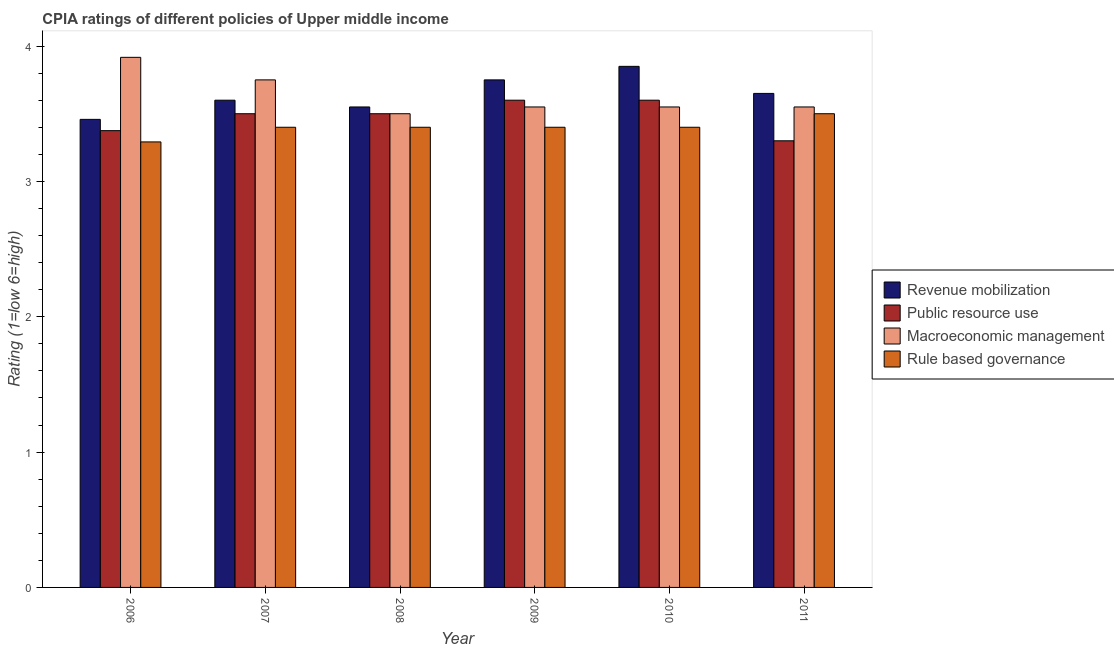How many groups of bars are there?
Keep it short and to the point. 6. Are the number of bars on each tick of the X-axis equal?
Provide a succinct answer. Yes. How many bars are there on the 2nd tick from the right?
Provide a short and direct response. 4. What is the label of the 4th group of bars from the left?
Your answer should be very brief. 2009. What is the cpia rating of rule based governance in 2010?
Your answer should be compact. 3.4. Across all years, what is the maximum cpia rating of revenue mobilization?
Keep it short and to the point. 3.85. Across all years, what is the minimum cpia rating of public resource use?
Make the answer very short. 3.3. In which year was the cpia rating of macroeconomic management maximum?
Offer a terse response. 2006. In which year was the cpia rating of revenue mobilization minimum?
Your answer should be very brief. 2006. What is the total cpia rating of rule based governance in the graph?
Keep it short and to the point. 20.39. What is the difference between the cpia rating of public resource use in 2006 and that in 2009?
Provide a short and direct response. -0.23. What is the difference between the cpia rating of revenue mobilization in 2008 and the cpia rating of macroeconomic management in 2007?
Offer a terse response. -0.05. What is the average cpia rating of rule based governance per year?
Your answer should be very brief. 3.4. In the year 2008, what is the difference between the cpia rating of public resource use and cpia rating of macroeconomic management?
Offer a very short reply. 0. In how many years, is the cpia rating of macroeconomic management greater than 3.4?
Offer a terse response. 6. What is the ratio of the cpia rating of rule based governance in 2010 to that in 2011?
Provide a short and direct response. 0.97. Is the cpia rating of public resource use in 2006 less than that in 2010?
Give a very brief answer. Yes. Is the difference between the cpia rating of rule based governance in 2008 and 2009 greater than the difference between the cpia rating of revenue mobilization in 2008 and 2009?
Provide a short and direct response. No. What is the difference between the highest and the second highest cpia rating of public resource use?
Provide a succinct answer. 0. What is the difference between the highest and the lowest cpia rating of revenue mobilization?
Make the answer very short. 0.39. Is the sum of the cpia rating of macroeconomic management in 2007 and 2010 greater than the maximum cpia rating of revenue mobilization across all years?
Keep it short and to the point. Yes. What does the 2nd bar from the left in 2007 represents?
Give a very brief answer. Public resource use. What does the 1st bar from the right in 2010 represents?
Provide a succinct answer. Rule based governance. Is it the case that in every year, the sum of the cpia rating of revenue mobilization and cpia rating of public resource use is greater than the cpia rating of macroeconomic management?
Ensure brevity in your answer.  Yes. Are all the bars in the graph horizontal?
Your answer should be compact. No. What is the difference between two consecutive major ticks on the Y-axis?
Give a very brief answer. 1. Are the values on the major ticks of Y-axis written in scientific E-notation?
Your answer should be very brief. No. Does the graph contain any zero values?
Give a very brief answer. No. Where does the legend appear in the graph?
Offer a very short reply. Center right. How many legend labels are there?
Keep it short and to the point. 4. What is the title of the graph?
Your response must be concise. CPIA ratings of different policies of Upper middle income. What is the label or title of the X-axis?
Provide a short and direct response. Year. What is the Rating (1=low 6=high) of Revenue mobilization in 2006?
Your answer should be compact. 3.46. What is the Rating (1=low 6=high) in Public resource use in 2006?
Offer a terse response. 3.38. What is the Rating (1=low 6=high) in Macroeconomic management in 2006?
Provide a short and direct response. 3.92. What is the Rating (1=low 6=high) in Rule based governance in 2006?
Provide a short and direct response. 3.29. What is the Rating (1=low 6=high) of Revenue mobilization in 2007?
Offer a terse response. 3.6. What is the Rating (1=low 6=high) of Macroeconomic management in 2007?
Provide a short and direct response. 3.75. What is the Rating (1=low 6=high) in Rule based governance in 2007?
Ensure brevity in your answer.  3.4. What is the Rating (1=low 6=high) of Revenue mobilization in 2008?
Give a very brief answer. 3.55. What is the Rating (1=low 6=high) of Rule based governance in 2008?
Ensure brevity in your answer.  3.4. What is the Rating (1=low 6=high) in Revenue mobilization in 2009?
Provide a succinct answer. 3.75. What is the Rating (1=low 6=high) of Macroeconomic management in 2009?
Offer a very short reply. 3.55. What is the Rating (1=low 6=high) of Rule based governance in 2009?
Provide a short and direct response. 3.4. What is the Rating (1=low 6=high) of Revenue mobilization in 2010?
Offer a terse response. 3.85. What is the Rating (1=low 6=high) in Public resource use in 2010?
Your response must be concise. 3.6. What is the Rating (1=low 6=high) in Macroeconomic management in 2010?
Your answer should be very brief. 3.55. What is the Rating (1=low 6=high) in Revenue mobilization in 2011?
Your answer should be very brief. 3.65. What is the Rating (1=low 6=high) in Macroeconomic management in 2011?
Your answer should be very brief. 3.55. Across all years, what is the maximum Rating (1=low 6=high) in Revenue mobilization?
Keep it short and to the point. 3.85. Across all years, what is the maximum Rating (1=low 6=high) of Public resource use?
Give a very brief answer. 3.6. Across all years, what is the maximum Rating (1=low 6=high) of Macroeconomic management?
Offer a very short reply. 3.92. Across all years, what is the minimum Rating (1=low 6=high) in Revenue mobilization?
Provide a succinct answer. 3.46. Across all years, what is the minimum Rating (1=low 6=high) in Public resource use?
Make the answer very short. 3.3. Across all years, what is the minimum Rating (1=low 6=high) in Macroeconomic management?
Your answer should be compact. 3.5. Across all years, what is the minimum Rating (1=low 6=high) of Rule based governance?
Your answer should be very brief. 3.29. What is the total Rating (1=low 6=high) of Revenue mobilization in the graph?
Your answer should be compact. 21.86. What is the total Rating (1=low 6=high) in Public resource use in the graph?
Your answer should be compact. 20.88. What is the total Rating (1=low 6=high) of Macroeconomic management in the graph?
Give a very brief answer. 21.82. What is the total Rating (1=low 6=high) in Rule based governance in the graph?
Make the answer very short. 20.39. What is the difference between the Rating (1=low 6=high) in Revenue mobilization in 2006 and that in 2007?
Offer a very short reply. -0.14. What is the difference between the Rating (1=low 6=high) of Public resource use in 2006 and that in 2007?
Provide a succinct answer. -0.12. What is the difference between the Rating (1=low 6=high) of Rule based governance in 2006 and that in 2007?
Your answer should be very brief. -0.11. What is the difference between the Rating (1=low 6=high) of Revenue mobilization in 2006 and that in 2008?
Offer a very short reply. -0.09. What is the difference between the Rating (1=low 6=high) in Public resource use in 2006 and that in 2008?
Give a very brief answer. -0.12. What is the difference between the Rating (1=low 6=high) of Macroeconomic management in 2006 and that in 2008?
Offer a terse response. 0.42. What is the difference between the Rating (1=low 6=high) in Rule based governance in 2006 and that in 2008?
Your answer should be very brief. -0.11. What is the difference between the Rating (1=low 6=high) of Revenue mobilization in 2006 and that in 2009?
Offer a very short reply. -0.29. What is the difference between the Rating (1=low 6=high) in Public resource use in 2006 and that in 2009?
Your response must be concise. -0.23. What is the difference between the Rating (1=low 6=high) of Macroeconomic management in 2006 and that in 2009?
Make the answer very short. 0.37. What is the difference between the Rating (1=low 6=high) in Rule based governance in 2006 and that in 2009?
Offer a terse response. -0.11. What is the difference between the Rating (1=low 6=high) of Revenue mobilization in 2006 and that in 2010?
Provide a succinct answer. -0.39. What is the difference between the Rating (1=low 6=high) in Public resource use in 2006 and that in 2010?
Your answer should be compact. -0.23. What is the difference between the Rating (1=low 6=high) of Macroeconomic management in 2006 and that in 2010?
Your answer should be compact. 0.37. What is the difference between the Rating (1=low 6=high) of Rule based governance in 2006 and that in 2010?
Your answer should be compact. -0.11. What is the difference between the Rating (1=low 6=high) of Revenue mobilization in 2006 and that in 2011?
Offer a very short reply. -0.19. What is the difference between the Rating (1=low 6=high) in Public resource use in 2006 and that in 2011?
Your answer should be compact. 0.07. What is the difference between the Rating (1=low 6=high) in Macroeconomic management in 2006 and that in 2011?
Offer a very short reply. 0.37. What is the difference between the Rating (1=low 6=high) in Rule based governance in 2006 and that in 2011?
Provide a short and direct response. -0.21. What is the difference between the Rating (1=low 6=high) in Public resource use in 2007 and that in 2008?
Ensure brevity in your answer.  0. What is the difference between the Rating (1=low 6=high) of Macroeconomic management in 2007 and that in 2008?
Give a very brief answer. 0.25. What is the difference between the Rating (1=low 6=high) in Rule based governance in 2007 and that in 2008?
Ensure brevity in your answer.  0. What is the difference between the Rating (1=low 6=high) of Revenue mobilization in 2007 and that in 2009?
Provide a short and direct response. -0.15. What is the difference between the Rating (1=low 6=high) in Public resource use in 2007 and that in 2009?
Your response must be concise. -0.1. What is the difference between the Rating (1=low 6=high) of Macroeconomic management in 2007 and that in 2009?
Offer a very short reply. 0.2. What is the difference between the Rating (1=low 6=high) in Rule based governance in 2007 and that in 2009?
Make the answer very short. 0. What is the difference between the Rating (1=low 6=high) in Public resource use in 2007 and that in 2011?
Provide a short and direct response. 0.2. What is the difference between the Rating (1=low 6=high) of Macroeconomic management in 2007 and that in 2011?
Your answer should be very brief. 0.2. What is the difference between the Rating (1=low 6=high) in Revenue mobilization in 2008 and that in 2009?
Keep it short and to the point. -0.2. What is the difference between the Rating (1=low 6=high) in Rule based governance in 2008 and that in 2010?
Provide a succinct answer. 0. What is the difference between the Rating (1=low 6=high) of Revenue mobilization in 2008 and that in 2011?
Your response must be concise. -0.1. What is the difference between the Rating (1=low 6=high) of Public resource use in 2008 and that in 2011?
Provide a succinct answer. 0.2. What is the difference between the Rating (1=low 6=high) in Macroeconomic management in 2008 and that in 2011?
Make the answer very short. -0.05. What is the difference between the Rating (1=low 6=high) of Revenue mobilization in 2009 and that in 2010?
Ensure brevity in your answer.  -0.1. What is the difference between the Rating (1=low 6=high) in Macroeconomic management in 2009 and that in 2010?
Make the answer very short. 0. What is the difference between the Rating (1=low 6=high) of Rule based governance in 2009 and that in 2010?
Your response must be concise. 0. What is the difference between the Rating (1=low 6=high) in Revenue mobilization in 2009 and that in 2011?
Your response must be concise. 0.1. What is the difference between the Rating (1=low 6=high) in Public resource use in 2009 and that in 2011?
Provide a short and direct response. 0.3. What is the difference between the Rating (1=low 6=high) of Rule based governance in 2009 and that in 2011?
Your answer should be very brief. -0.1. What is the difference between the Rating (1=low 6=high) of Revenue mobilization in 2006 and the Rating (1=low 6=high) of Public resource use in 2007?
Provide a succinct answer. -0.04. What is the difference between the Rating (1=low 6=high) in Revenue mobilization in 2006 and the Rating (1=low 6=high) in Macroeconomic management in 2007?
Provide a short and direct response. -0.29. What is the difference between the Rating (1=low 6=high) of Revenue mobilization in 2006 and the Rating (1=low 6=high) of Rule based governance in 2007?
Ensure brevity in your answer.  0.06. What is the difference between the Rating (1=low 6=high) of Public resource use in 2006 and the Rating (1=low 6=high) of Macroeconomic management in 2007?
Provide a short and direct response. -0.38. What is the difference between the Rating (1=low 6=high) in Public resource use in 2006 and the Rating (1=low 6=high) in Rule based governance in 2007?
Keep it short and to the point. -0.03. What is the difference between the Rating (1=low 6=high) in Macroeconomic management in 2006 and the Rating (1=low 6=high) in Rule based governance in 2007?
Your answer should be compact. 0.52. What is the difference between the Rating (1=low 6=high) in Revenue mobilization in 2006 and the Rating (1=low 6=high) in Public resource use in 2008?
Provide a succinct answer. -0.04. What is the difference between the Rating (1=low 6=high) in Revenue mobilization in 2006 and the Rating (1=low 6=high) in Macroeconomic management in 2008?
Offer a very short reply. -0.04. What is the difference between the Rating (1=low 6=high) of Revenue mobilization in 2006 and the Rating (1=low 6=high) of Rule based governance in 2008?
Ensure brevity in your answer.  0.06. What is the difference between the Rating (1=low 6=high) of Public resource use in 2006 and the Rating (1=low 6=high) of Macroeconomic management in 2008?
Keep it short and to the point. -0.12. What is the difference between the Rating (1=low 6=high) of Public resource use in 2006 and the Rating (1=low 6=high) of Rule based governance in 2008?
Provide a short and direct response. -0.03. What is the difference between the Rating (1=low 6=high) in Macroeconomic management in 2006 and the Rating (1=low 6=high) in Rule based governance in 2008?
Your response must be concise. 0.52. What is the difference between the Rating (1=low 6=high) in Revenue mobilization in 2006 and the Rating (1=low 6=high) in Public resource use in 2009?
Make the answer very short. -0.14. What is the difference between the Rating (1=low 6=high) in Revenue mobilization in 2006 and the Rating (1=low 6=high) in Macroeconomic management in 2009?
Your answer should be very brief. -0.09. What is the difference between the Rating (1=low 6=high) in Revenue mobilization in 2006 and the Rating (1=low 6=high) in Rule based governance in 2009?
Provide a short and direct response. 0.06. What is the difference between the Rating (1=low 6=high) of Public resource use in 2006 and the Rating (1=low 6=high) of Macroeconomic management in 2009?
Ensure brevity in your answer.  -0.17. What is the difference between the Rating (1=low 6=high) in Public resource use in 2006 and the Rating (1=low 6=high) in Rule based governance in 2009?
Make the answer very short. -0.03. What is the difference between the Rating (1=low 6=high) of Macroeconomic management in 2006 and the Rating (1=low 6=high) of Rule based governance in 2009?
Ensure brevity in your answer.  0.52. What is the difference between the Rating (1=low 6=high) of Revenue mobilization in 2006 and the Rating (1=low 6=high) of Public resource use in 2010?
Ensure brevity in your answer.  -0.14. What is the difference between the Rating (1=low 6=high) in Revenue mobilization in 2006 and the Rating (1=low 6=high) in Macroeconomic management in 2010?
Provide a short and direct response. -0.09. What is the difference between the Rating (1=low 6=high) of Revenue mobilization in 2006 and the Rating (1=low 6=high) of Rule based governance in 2010?
Your answer should be very brief. 0.06. What is the difference between the Rating (1=low 6=high) of Public resource use in 2006 and the Rating (1=low 6=high) of Macroeconomic management in 2010?
Give a very brief answer. -0.17. What is the difference between the Rating (1=low 6=high) of Public resource use in 2006 and the Rating (1=low 6=high) of Rule based governance in 2010?
Offer a very short reply. -0.03. What is the difference between the Rating (1=low 6=high) of Macroeconomic management in 2006 and the Rating (1=low 6=high) of Rule based governance in 2010?
Your answer should be compact. 0.52. What is the difference between the Rating (1=low 6=high) of Revenue mobilization in 2006 and the Rating (1=low 6=high) of Public resource use in 2011?
Make the answer very short. 0.16. What is the difference between the Rating (1=low 6=high) in Revenue mobilization in 2006 and the Rating (1=low 6=high) in Macroeconomic management in 2011?
Ensure brevity in your answer.  -0.09. What is the difference between the Rating (1=low 6=high) in Revenue mobilization in 2006 and the Rating (1=low 6=high) in Rule based governance in 2011?
Offer a very short reply. -0.04. What is the difference between the Rating (1=low 6=high) of Public resource use in 2006 and the Rating (1=low 6=high) of Macroeconomic management in 2011?
Your response must be concise. -0.17. What is the difference between the Rating (1=low 6=high) in Public resource use in 2006 and the Rating (1=low 6=high) in Rule based governance in 2011?
Your answer should be compact. -0.12. What is the difference between the Rating (1=low 6=high) in Macroeconomic management in 2006 and the Rating (1=low 6=high) in Rule based governance in 2011?
Your answer should be very brief. 0.42. What is the difference between the Rating (1=low 6=high) in Revenue mobilization in 2007 and the Rating (1=low 6=high) in Rule based governance in 2008?
Make the answer very short. 0.2. What is the difference between the Rating (1=low 6=high) in Public resource use in 2007 and the Rating (1=low 6=high) in Macroeconomic management in 2008?
Give a very brief answer. 0. What is the difference between the Rating (1=low 6=high) in Macroeconomic management in 2007 and the Rating (1=low 6=high) in Rule based governance in 2008?
Your answer should be very brief. 0.35. What is the difference between the Rating (1=low 6=high) of Revenue mobilization in 2007 and the Rating (1=low 6=high) of Macroeconomic management in 2009?
Provide a short and direct response. 0.05. What is the difference between the Rating (1=low 6=high) of Public resource use in 2007 and the Rating (1=low 6=high) of Macroeconomic management in 2009?
Make the answer very short. -0.05. What is the difference between the Rating (1=low 6=high) in Public resource use in 2007 and the Rating (1=low 6=high) in Rule based governance in 2009?
Ensure brevity in your answer.  0.1. What is the difference between the Rating (1=low 6=high) in Revenue mobilization in 2007 and the Rating (1=low 6=high) in Public resource use in 2010?
Provide a short and direct response. 0. What is the difference between the Rating (1=low 6=high) of Revenue mobilization in 2007 and the Rating (1=low 6=high) of Rule based governance in 2010?
Offer a very short reply. 0.2. What is the difference between the Rating (1=low 6=high) of Public resource use in 2007 and the Rating (1=low 6=high) of Macroeconomic management in 2010?
Ensure brevity in your answer.  -0.05. What is the difference between the Rating (1=low 6=high) of Revenue mobilization in 2007 and the Rating (1=low 6=high) of Rule based governance in 2011?
Your answer should be compact. 0.1. What is the difference between the Rating (1=low 6=high) in Macroeconomic management in 2007 and the Rating (1=low 6=high) in Rule based governance in 2011?
Your answer should be very brief. 0.25. What is the difference between the Rating (1=low 6=high) of Revenue mobilization in 2008 and the Rating (1=low 6=high) of Macroeconomic management in 2009?
Your response must be concise. 0. What is the difference between the Rating (1=low 6=high) of Revenue mobilization in 2008 and the Rating (1=low 6=high) of Rule based governance in 2009?
Your response must be concise. 0.15. What is the difference between the Rating (1=low 6=high) in Revenue mobilization in 2008 and the Rating (1=low 6=high) in Public resource use in 2010?
Ensure brevity in your answer.  -0.05. What is the difference between the Rating (1=low 6=high) of Revenue mobilization in 2008 and the Rating (1=low 6=high) of Macroeconomic management in 2010?
Offer a very short reply. 0. What is the difference between the Rating (1=low 6=high) in Public resource use in 2008 and the Rating (1=low 6=high) in Macroeconomic management in 2010?
Offer a terse response. -0.05. What is the difference between the Rating (1=low 6=high) in Macroeconomic management in 2008 and the Rating (1=low 6=high) in Rule based governance in 2010?
Your answer should be compact. 0.1. What is the difference between the Rating (1=low 6=high) in Revenue mobilization in 2008 and the Rating (1=low 6=high) in Macroeconomic management in 2011?
Your answer should be very brief. 0. What is the difference between the Rating (1=low 6=high) in Public resource use in 2008 and the Rating (1=low 6=high) in Macroeconomic management in 2011?
Offer a very short reply. -0.05. What is the difference between the Rating (1=low 6=high) of Macroeconomic management in 2008 and the Rating (1=low 6=high) of Rule based governance in 2011?
Provide a short and direct response. 0. What is the difference between the Rating (1=low 6=high) of Revenue mobilization in 2009 and the Rating (1=low 6=high) of Rule based governance in 2010?
Offer a terse response. 0.35. What is the difference between the Rating (1=low 6=high) in Public resource use in 2009 and the Rating (1=low 6=high) in Macroeconomic management in 2010?
Provide a short and direct response. 0.05. What is the difference between the Rating (1=low 6=high) of Public resource use in 2009 and the Rating (1=low 6=high) of Rule based governance in 2010?
Your answer should be very brief. 0.2. What is the difference between the Rating (1=low 6=high) of Macroeconomic management in 2009 and the Rating (1=low 6=high) of Rule based governance in 2010?
Make the answer very short. 0.15. What is the difference between the Rating (1=low 6=high) of Revenue mobilization in 2009 and the Rating (1=low 6=high) of Public resource use in 2011?
Offer a terse response. 0.45. What is the difference between the Rating (1=low 6=high) of Revenue mobilization in 2009 and the Rating (1=low 6=high) of Macroeconomic management in 2011?
Provide a short and direct response. 0.2. What is the difference between the Rating (1=low 6=high) of Revenue mobilization in 2010 and the Rating (1=low 6=high) of Public resource use in 2011?
Ensure brevity in your answer.  0.55. What is the difference between the Rating (1=low 6=high) of Revenue mobilization in 2010 and the Rating (1=low 6=high) of Rule based governance in 2011?
Offer a terse response. 0.35. What is the average Rating (1=low 6=high) of Revenue mobilization per year?
Keep it short and to the point. 3.64. What is the average Rating (1=low 6=high) in Public resource use per year?
Offer a terse response. 3.48. What is the average Rating (1=low 6=high) of Macroeconomic management per year?
Keep it short and to the point. 3.64. What is the average Rating (1=low 6=high) in Rule based governance per year?
Your answer should be compact. 3.4. In the year 2006, what is the difference between the Rating (1=low 6=high) in Revenue mobilization and Rating (1=low 6=high) in Public resource use?
Provide a short and direct response. 0.08. In the year 2006, what is the difference between the Rating (1=low 6=high) of Revenue mobilization and Rating (1=low 6=high) of Macroeconomic management?
Make the answer very short. -0.46. In the year 2006, what is the difference between the Rating (1=low 6=high) of Revenue mobilization and Rating (1=low 6=high) of Rule based governance?
Your answer should be very brief. 0.17. In the year 2006, what is the difference between the Rating (1=low 6=high) of Public resource use and Rating (1=low 6=high) of Macroeconomic management?
Your answer should be compact. -0.54. In the year 2006, what is the difference between the Rating (1=low 6=high) in Public resource use and Rating (1=low 6=high) in Rule based governance?
Provide a succinct answer. 0.08. In the year 2007, what is the difference between the Rating (1=low 6=high) of Revenue mobilization and Rating (1=low 6=high) of Macroeconomic management?
Keep it short and to the point. -0.15. In the year 2007, what is the difference between the Rating (1=low 6=high) in Revenue mobilization and Rating (1=low 6=high) in Rule based governance?
Your response must be concise. 0.2. In the year 2008, what is the difference between the Rating (1=low 6=high) of Revenue mobilization and Rating (1=low 6=high) of Macroeconomic management?
Provide a short and direct response. 0.05. In the year 2008, what is the difference between the Rating (1=low 6=high) of Public resource use and Rating (1=low 6=high) of Rule based governance?
Your answer should be compact. 0.1. In the year 2009, what is the difference between the Rating (1=low 6=high) in Revenue mobilization and Rating (1=low 6=high) in Macroeconomic management?
Make the answer very short. 0.2. In the year 2009, what is the difference between the Rating (1=low 6=high) in Macroeconomic management and Rating (1=low 6=high) in Rule based governance?
Offer a very short reply. 0.15. In the year 2010, what is the difference between the Rating (1=low 6=high) in Revenue mobilization and Rating (1=low 6=high) in Macroeconomic management?
Make the answer very short. 0.3. In the year 2010, what is the difference between the Rating (1=low 6=high) of Revenue mobilization and Rating (1=low 6=high) of Rule based governance?
Provide a succinct answer. 0.45. In the year 2010, what is the difference between the Rating (1=low 6=high) of Public resource use and Rating (1=low 6=high) of Macroeconomic management?
Offer a terse response. 0.05. In the year 2010, what is the difference between the Rating (1=low 6=high) of Macroeconomic management and Rating (1=low 6=high) of Rule based governance?
Provide a short and direct response. 0.15. In the year 2011, what is the difference between the Rating (1=low 6=high) in Macroeconomic management and Rating (1=low 6=high) in Rule based governance?
Your answer should be very brief. 0.05. What is the ratio of the Rating (1=low 6=high) in Revenue mobilization in 2006 to that in 2007?
Your response must be concise. 0.96. What is the ratio of the Rating (1=low 6=high) of Macroeconomic management in 2006 to that in 2007?
Keep it short and to the point. 1.04. What is the ratio of the Rating (1=low 6=high) of Rule based governance in 2006 to that in 2007?
Provide a short and direct response. 0.97. What is the ratio of the Rating (1=low 6=high) in Revenue mobilization in 2006 to that in 2008?
Provide a short and direct response. 0.97. What is the ratio of the Rating (1=low 6=high) of Macroeconomic management in 2006 to that in 2008?
Keep it short and to the point. 1.12. What is the ratio of the Rating (1=low 6=high) in Rule based governance in 2006 to that in 2008?
Ensure brevity in your answer.  0.97. What is the ratio of the Rating (1=low 6=high) in Revenue mobilization in 2006 to that in 2009?
Your response must be concise. 0.92. What is the ratio of the Rating (1=low 6=high) in Public resource use in 2006 to that in 2009?
Offer a terse response. 0.94. What is the ratio of the Rating (1=low 6=high) of Macroeconomic management in 2006 to that in 2009?
Make the answer very short. 1.1. What is the ratio of the Rating (1=low 6=high) of Rule based governance in 2006 to that in 2009?
Make the answer very short. 0.97. What is the ratio of the Rating (1=low 6=high) of Revenue mobilization in 2006 to that in 2010?
Ensure brevity in your answer.  0.9. What is the ratio of the Rating (1=low 6=high) in Macroeconomic management in 2006 to that in 2010?
Your response must be concise. 1.1. What is the ratio of the Rating (1=low 6=high) in Rule based governance in 2006 to that in 2010?
Give a very brief answer. 0.97. What is the ratio of the Rating (1=low 6=high) of Revenue mobilization in 2006 to that in 2011?
Ensure brevity in your answer.  0.95. What is the ratio of the Rating (1=low 6=high) of Public resource use in 2006 to that in 2011?
Offer a terse response. 1.02. What is the ratio of the Rating (1=low 6=high) of Macroeconomic management in 2006 to that in 2011?
Ensure brevity in your answer.  1.1. What is the ratio of the Rating (1=low 6=high) of Rule based governance in 2006 to that in 2011?
Ensure brevity in your answer.  0.94. What is the ratio of the Rating (1=low 6=high) of Revenue mobilization in 2007 to that in 2008?
Your answer should be compact. 1.01. What is the ratio of the Rating (1=low 6=high) of Public resource use in 2007 to that in 2008?
Your response must be concise. 1. What is the ratio of the Rating (1=low 6=high) of Macroeconomic management in 2007 to that in 2008?
Ensure brevity in your answer.  1.07. What is the ratio of the Rating (1=low 6=high) of Rule based governance in 2007 to that in 2008?
Offer a very short reply. 1. What is the ratio of the Rating (1=low 6=high) in Revenue mobilization in 2007 to that in 2009?
Offer a very short reply. 0.96. What is the ratio of the Rating (1=low 6=high) in Public resource use in 2007 to that in 2009?
Offer a terse response. 0.97. What is the ratio of the Rating (1=low 6=high) of Macroeconomic management in 2007 to that in 2009?
Offer a terse response. 1.06. What is the ratio of the Rating (1=low 6=high) in Rule based governance in 2007 to that in 2009?
Give a very brief answer. 1. What is the ratio of the Rating (1=low 6=high) in Revenue mobilization in 2007 to that in 2010?
Your answer should be compact. 0.94. What is the ratio of the Rating (1=low 6=high) of Public resource use in 2007 to that in 2010?
Provide a succinct answer. 0.97. What is the ratio of the Rating (1=low 6=high) of Macroeconomic management in 2007 to that in 2010?
Make the answer very short. 1.06. What is the ratio of the Rating (1=low 6=high) in Rule based governance in 2007 to that in 2010?
Offer a very short reply. 1. What is the ratio of the Rating (1=low 6=high) of Revenue mobilization in 2007 to that in 2011?
Your answer should be very brief. 0.99. What is the ratio of the Rating (1=low 6=high) in Public resource use in 2007 to that in 2011?
Your response must be concise. 1.06. What is the ratio of the Rating (1=low 6=high) in Macroeconomic management in 2007 to that in 2011?
Your response must be concise. 1.06. What is the ratio of the Rating (1=low 6=high) in Rule based governance in 2007 to that in 2011?
Provide a succinct answer. 0.97. What is the ratio of the Rating (1=low 6=high) of Revenue mobilization in 2008 to that in 2009?
Provide a short and direct response. 0.95. What is the ratio of the Rating (1=low 6=high) in Public resource use in 2008 to that in 2009?
Your response must be concise. 0.97. What is the ratio of the Rating (1=low 6=high) of Macroeconomic management in 2008 to that in 2009?
Make the answer very short. 0.99. What is the ratio of the Rating (1=low 6=high) in Rule based governance in 2008 to that in 2009?
Ensure brevity in your answer.  1. What is the ratio of the Rating (1=low 6=high) of Revenue mobilization in 2008 to that in 2010?
Keep it short and to the point. 0.92. What is the ratio of the Rating (1=low 6=high) in Public resource use in 2008 to that in 2010?
Make the answer very short. 0.97. What is the ratio of the Rating (1=low 6=high) of Macroeconomic management in 2008 to that in 2010?
Make the answer very short. 0.99. What is the ratio of the Rating (1=low 6=high) in Rule based governance in 2008 to that in 2010?
Your response must be concise. 1. What is the ratio of the Rating (1=low 6=high) in Revenue mobilization in 2008 to that in 2011?
Offer a very short reply. 0.97. What is the ratio of the Rating (1=low 6=high) in Public resource use in 2008 to that in 2011?
Keep it short and to the point. 1.06. What is the ratio of the Rating (1=low 6=high) in Macroeconomic management in 2008 to that in 2011?
Your response must be concise. 0.99. What is the ratio of the Rating (1=low 6=high) of Rule based governance in 2008 to that in 2011?
Your answer should be compact. 0.97. What is the ratio of the Rating (1=low 6=high) of Revenue mobilization in 2009 to that in 2010?
Ensure brevity in your answer.  0.97. What is the ratio of the Rating (1=low 6=high) of Revenue mobilization in 2009 to that in 2011?
Keep it short and to the point. 1.03. What is the ratio of the Rating (1=low 6=high) in Rule based governance in 2009 to that in 2011?
Keep it short and to the point. 0.97. What is the ratio of the Rating (1=low 6=high) of Revenue mobilization in 2010 to that in 2011?
Make the answer very short. 1.05. What is the ratio of the Rating (1=low 6=high) in Public resource use in 2010 to that in 2011?
Your answer should be compact. 1.09. What is the ratio of the Rating (1=low 6=high) in Macroeconomic management in 2010 to that in 2011?
Ensure brevity in your answer.  1. What is the ratio of the Rating (1=low 6=high) of Rule based governance in 2010 to that in 2011?
Offer a terse response. 0.97. What is the difference between the highest and the second highest Rating (1=low 6=high) in Revenue mobilization?
Give a very brief answer. 0.1. What is the difference between the highest and the second highest Rating (1=low 6=high) in Macroeconomic management?
Keep it short and to the point. 0.17. What is the difference between the highest and the second highest Rating (1=low 6=high) of Rule based governance?
Give a very brief answer. 0.1. What is the difference between the highest and the lowest Rating (1=low 6=high) in Revenue mobilization?
Offer a terse response. 0.39. What is the difference between the highest and the lowest Rating (1=low 6=high) of Macroeconomic management?
Keep it short and to the point. 0.42. What is the difference between the highest and the lowest Rating (1=low 6=high) in Rule based governance?
Keep it short and to the point. 0.21. 